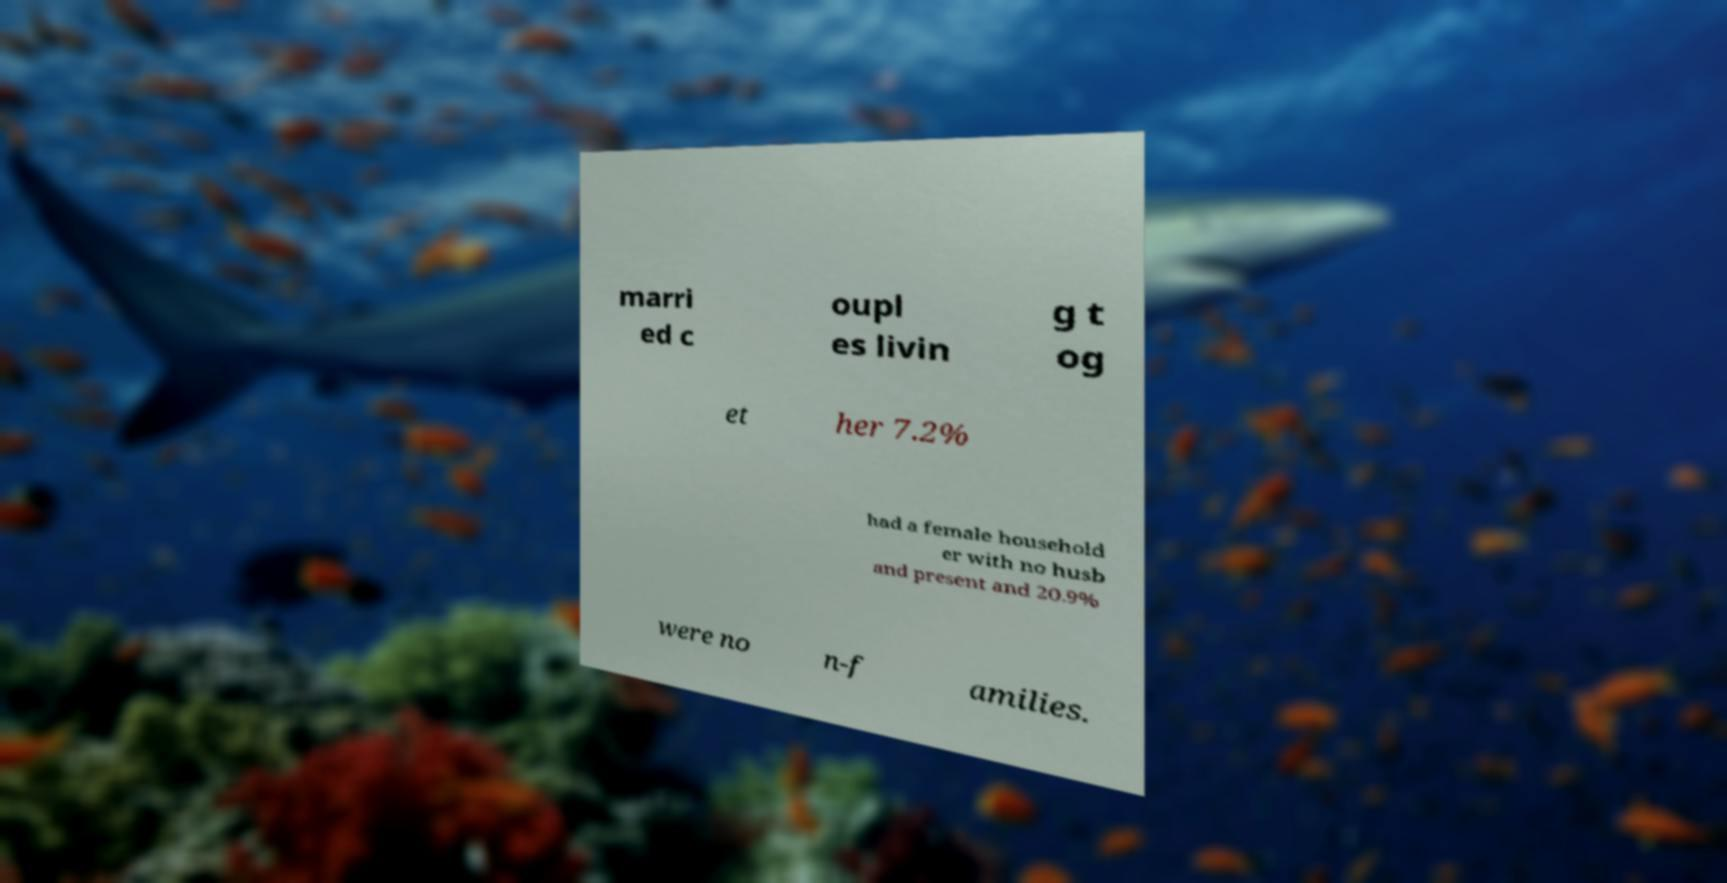Please read and relay the text visible in this image. What does it say? marri ed c oupl es livin g t og et her 7.2% had a female household er with no husb and present and 20.9% were no n-f amilies. 